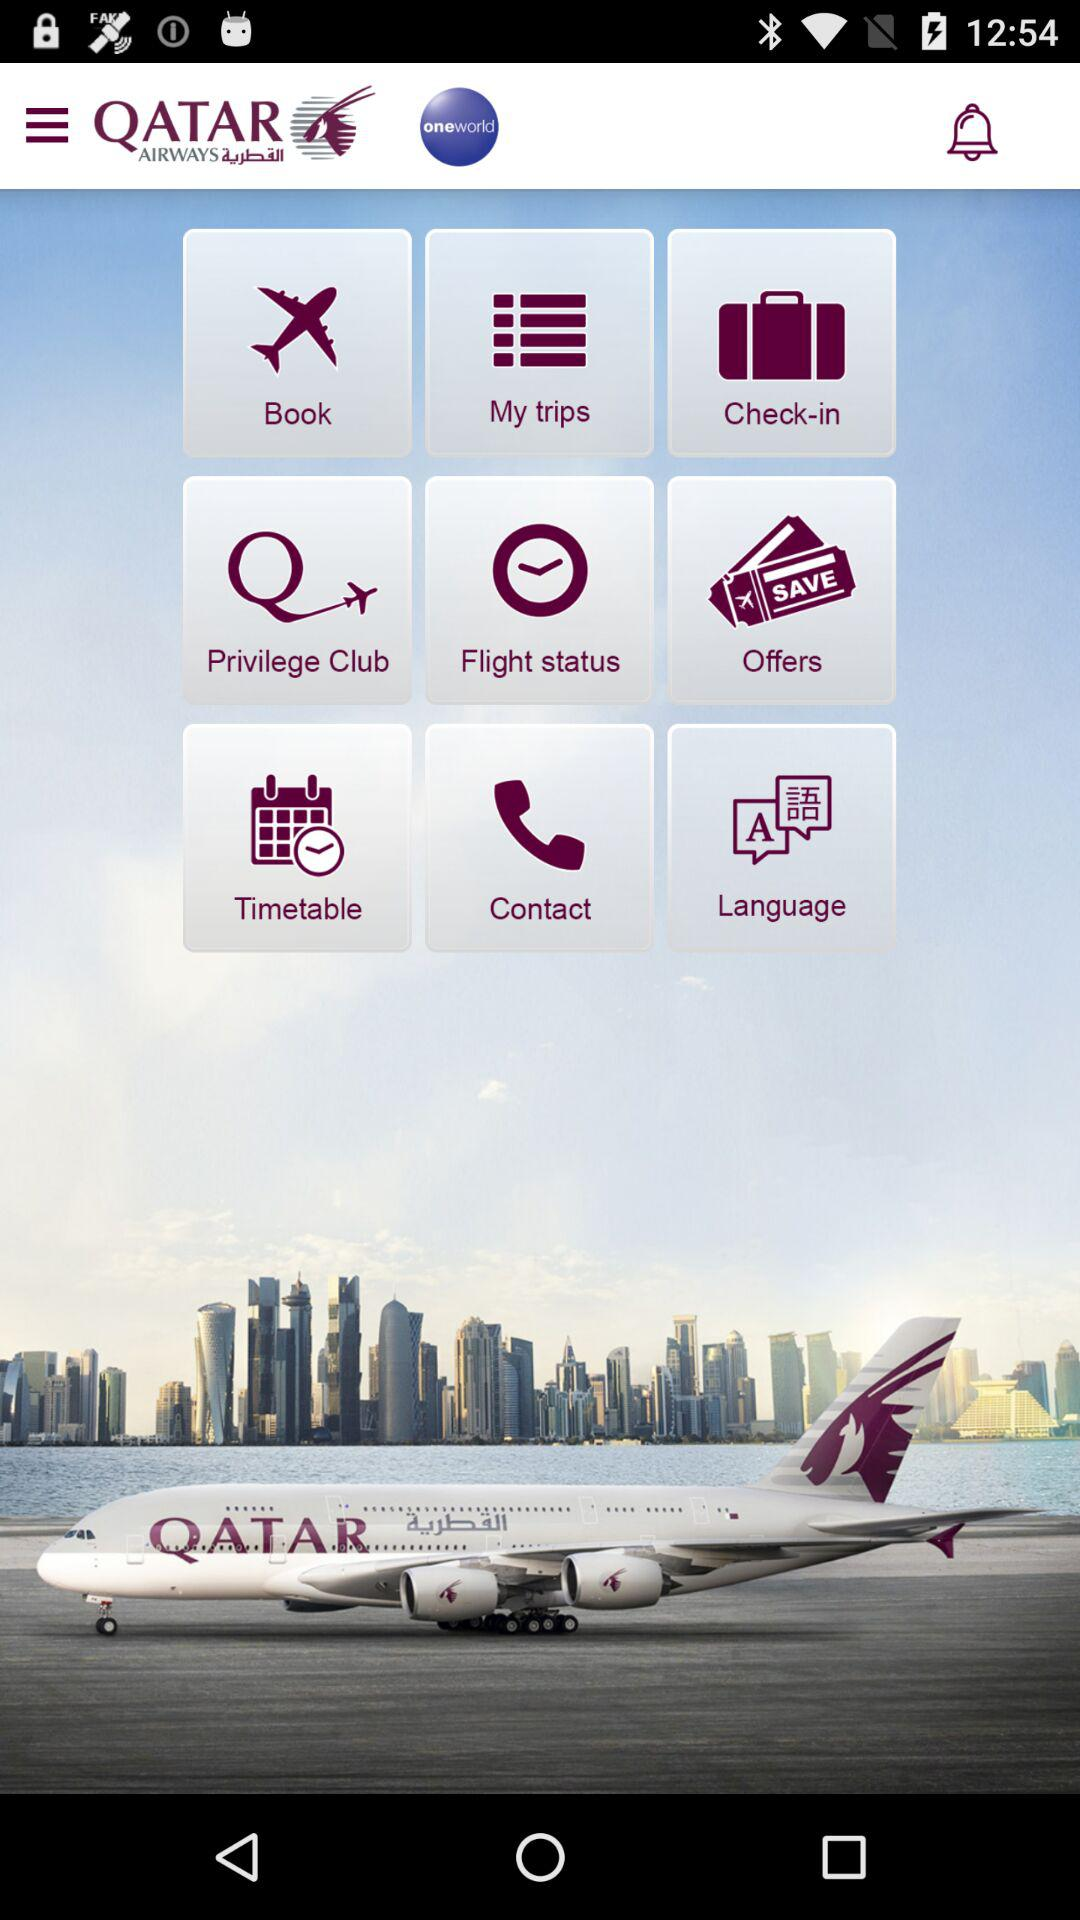What is the name of the application? The name of the application is "Qatar Airways". 